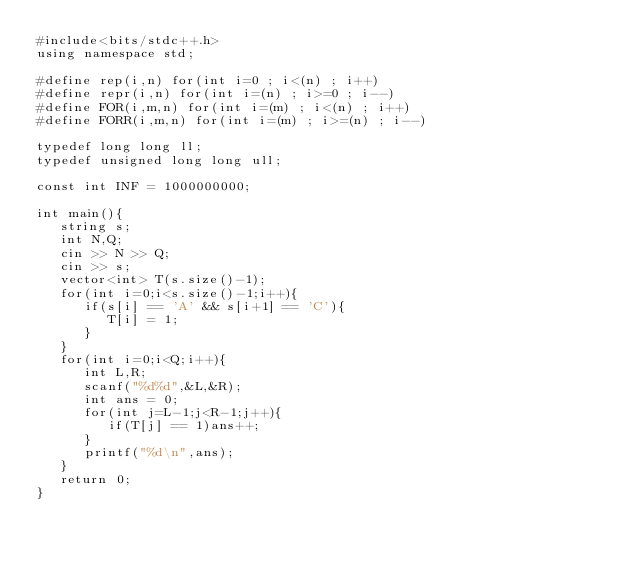Convert code to text. <code><loc_0><loc_0><loc_500><loc_500><_C++_>#include<bits/stdc++.h>
using namespace std;

#define rep(i,n) for(int i=0 ; i<(n) ; i++)
#define repr(i,n) for(int i=(n) ; i>=0 ; i--)
#define FOR(i,m,n) for(int i=(m) ; i<(n) ; i++)
#define FORR(i,m,n) for(int i=(m) ; i>=(n) ; i--)

typedef long long ll;
typedef unsigned long long ull;

const int INF = 1000000000;

int main(){
   string s;
   int N,Q;
   cin >> N >> Q;
   cin >> s;
   vector<int> T(s.size()-1);
   for(int i=0;i<s.size()-1;i++){
      if(s[i] == 'A' && s[i+1] == 'C'){
         T[i] = 1;
      }
   }
   for(int i=0;i<Q;i++){
      int L,R;
      scanf("%d%d",&L,&R);
      int ans = 0;
      for(int j=L-1;j<R-1;j++){
         if(T[j] == 1)ans++;
      }
      printf("%d\n",ans);
   }
   return 0;
}</code> 